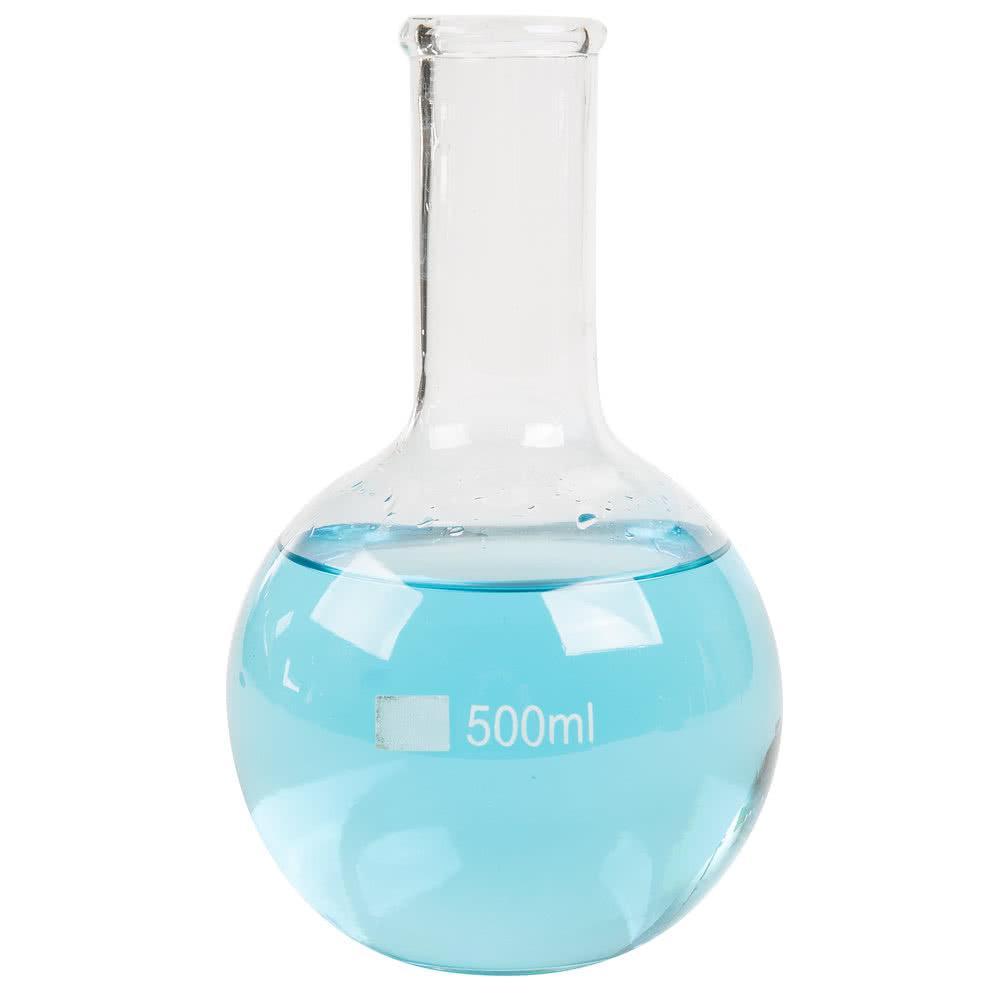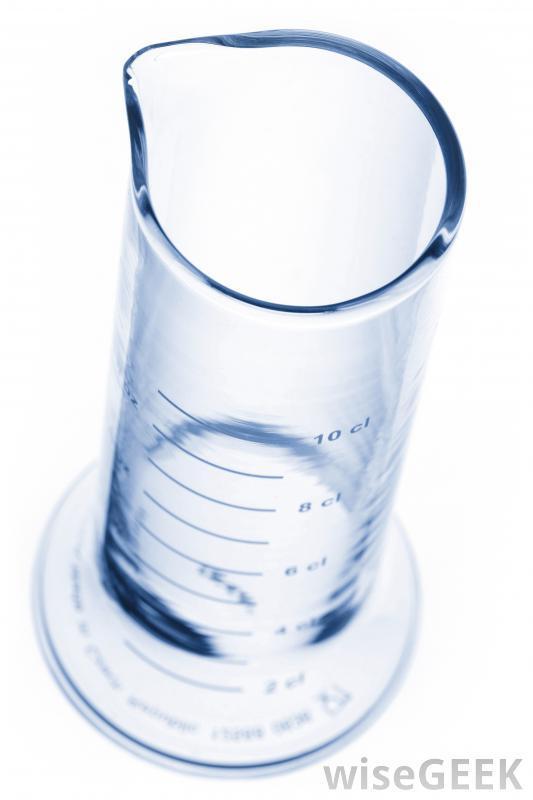The first image is the image on the left, the second image is the image on the right. Assess this claim about the two images: "There is no less than one clear beaker filled with a blue liquid". Correct or not? Answer yes or no. Yes. The first image is the image on the left, the second image is the image on the right. Assess this claim about the two images: "The image to the left contains a flask with a blue tinted liquid inside.". Correct or not? Answer yes or no. Yes. 